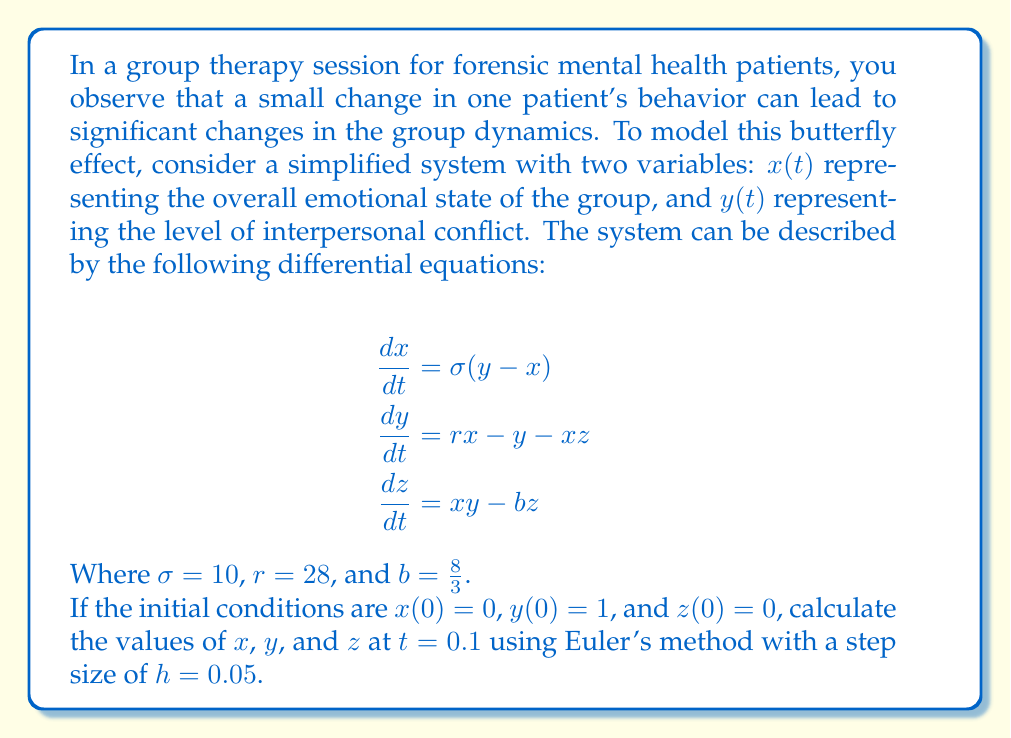Solve this math problem. To solve this problem using Euler's method, we'll follow these steps:

1) Euler's method is given by the formula:
   $$x_{n+1} = x_n + h f(x_n, y_n, z_n)$$
   $$y_{n+1} = y_n + h g(x_n, y_n, z_n)$$
   $$z_{n+1} = z_n + h k(x_n, y_n, z_n)$$

   Where $f$, $g$, and $k$ are the right-hand sides of the differential equations.

2) We'll need to calculate two steps to reach $t = 0.1$ with $h = 0.05$.

3) For the first step ($n = 0$):
   $$x_1 = 0 + 0.05(10(1 - 0)) = 0.5$$
   $$y_1 = 1 + 0.05(28(0) - 1 - 0(0)) = 0.95$$
   $$z_1 = 0 + 0.05(0(1) - \frac{8}{3}(0)) = 0$$

4) For the second step ($n = 1$):
   $$x_2 = 0.5 + 0.05(10(0.95 - 0.5)) = 0.725$$
   $$y_2 = 0.95 + 0.05(28(0.5) - 0.95 - 0.5(0)) = 1.5875$$
   $$z_2 = 0 + 0.05(0.5(0.95) - \frac{8}{3}(0)) = 0.02375$$

5) Therefore, at $t = 0.1$, we have:
   $x(0.1) \approx 0.725$
   $y(0.1) \approx 1.5875$
   $z(0.1) \approx 0.02375$
Answer: $(0.725, 1.5875, 0.02375)$ 